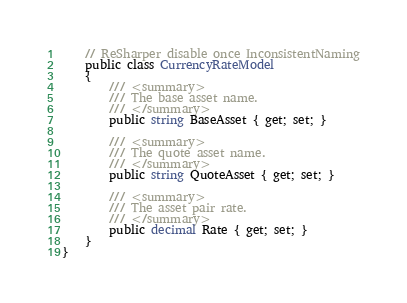<code> <loc_0><loc_0><loc_500><loc_500><_C#_>    // ReSharper disable once InconsistentNaming
    public class CurrencyRateModel
    {
        /// <summary>
        /// The base asset name.
        /// </summary>
        public string BaseAsset { get; set; }

        /// <summary>
        /// The quote asset name.
        /// </summary>
        public string QuoteAsset { get; set; }

        /// <summary>
        /// The asset pair rate.
        /// </summary>
        public decimal Rate { get; set; }
    }
}
</code> 